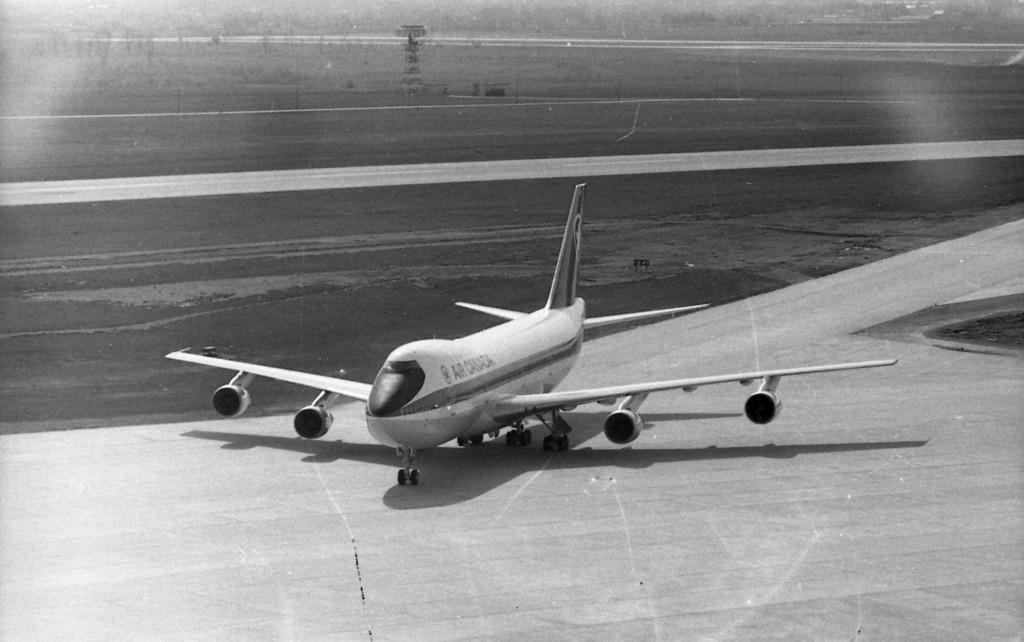<image>
Share a concise interpretation of the image provided. A large Air Canada passenger jet is taxiing on a runway. 